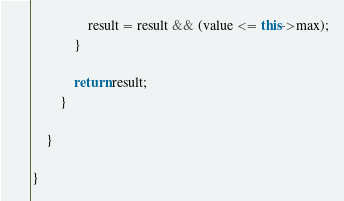Convert code to text. <code><loc_0><loc_0><loc_500><loc_500><_C++_>				result = result && (value <= this->max);
			}

			return result;
		}

	}

}
</code> 